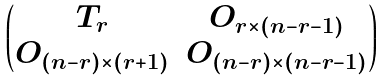Convert formula to latex. <formula><loc_0><loc_0><loc_500><loc_500>\begin{pmatrix} T _ { r } & O _ { r \times ( n - r - 1 ) } \\ O _ { ( n - r ) \times ( r + 1 ) } & O _ { ( n - r ) \times ( n - r - 1 ) } \\ \end{pmatrix}</formula> 